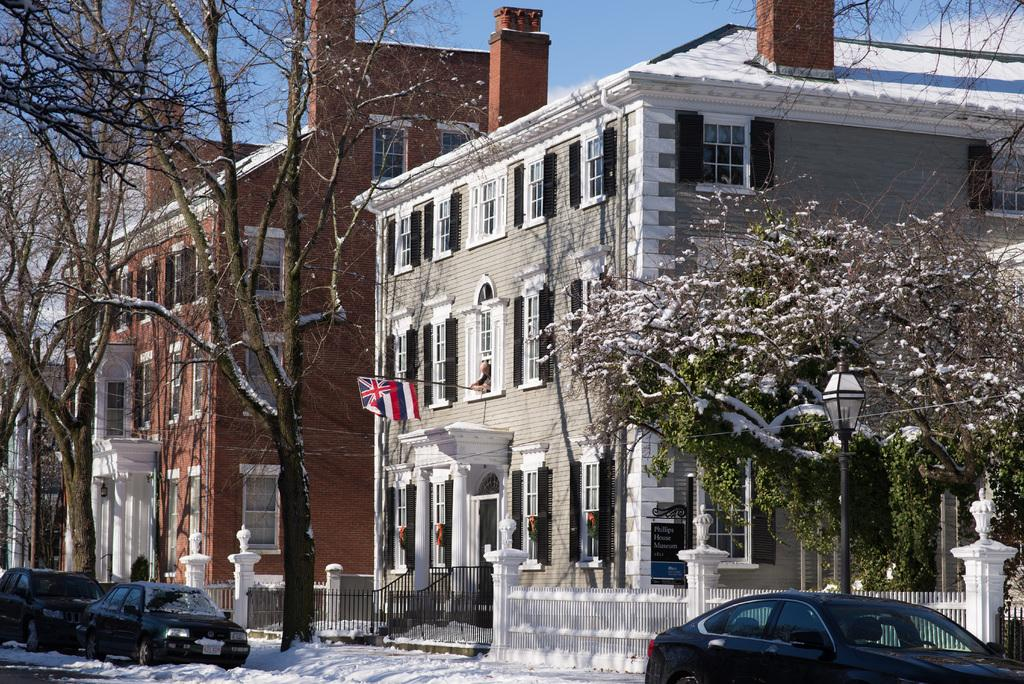What type of structures can be seen in the image? There are buildings with windows in the image. What natural elements are present in the image? There are trees and plants in the image. What man-made objects can be seen in the image? There are vehicles, a flag, and light poles in the image. What part of the natural environment is visible in the image? The sky is visible in the image. What letters are the sidewalks spelling out in the image? There is no mention of sidewalks in the image, so we cannot determine what letters they might be spelling out. 